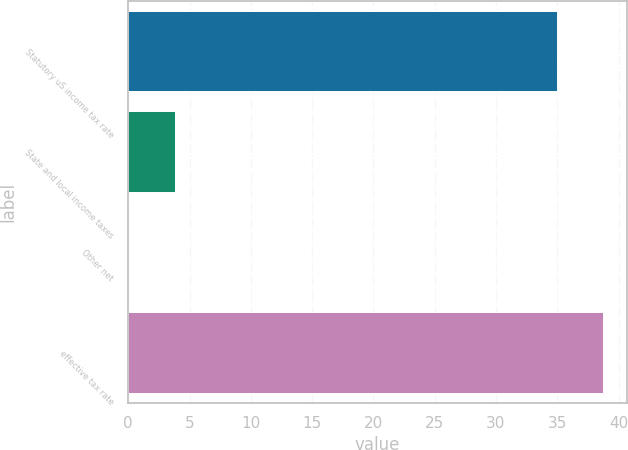<chart> <loc_0><loc_0><loc_500><loc_500><bar_chart><fcel>Statutory uS income tax rate<fcel>State and local income taxes<fcel>Other net<fcel>effective tax rate<nl><fcel>35<fcel>3.84<fcel>0.1<fcel>38.74<nl></chart> 